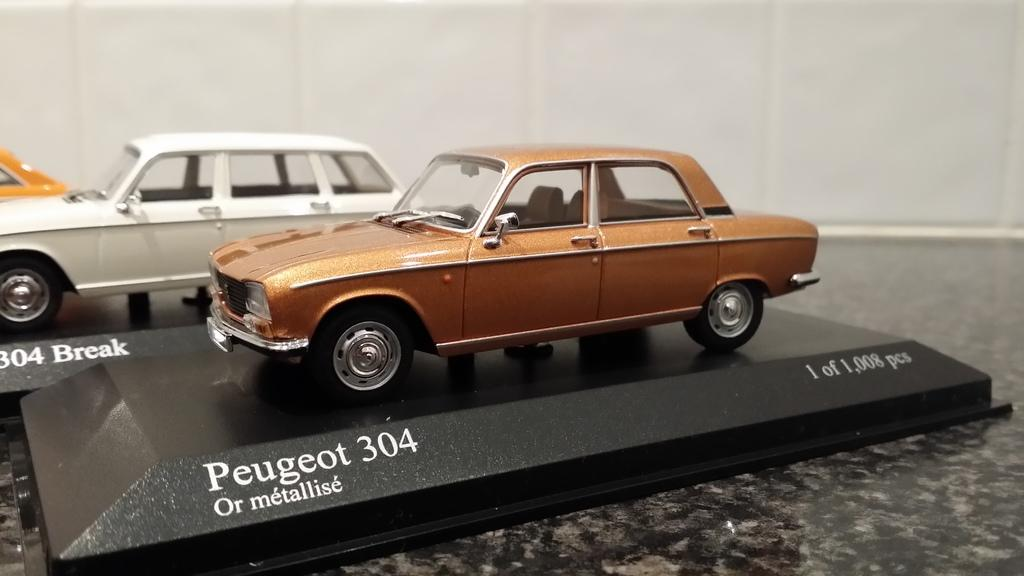What is the main subject in the center of the image? There is a small model of a car in the center of the image. Can you describe the background of the image? There are other cars in the background of the image. Are there any cherries on the small model of the car in the image? There are no cherries present on the small model of the car in the image. Is the small model of the car sitting on a bed of sand in the image? There is no sand present in the image, and the small model of the car is not sitting on any sand. 